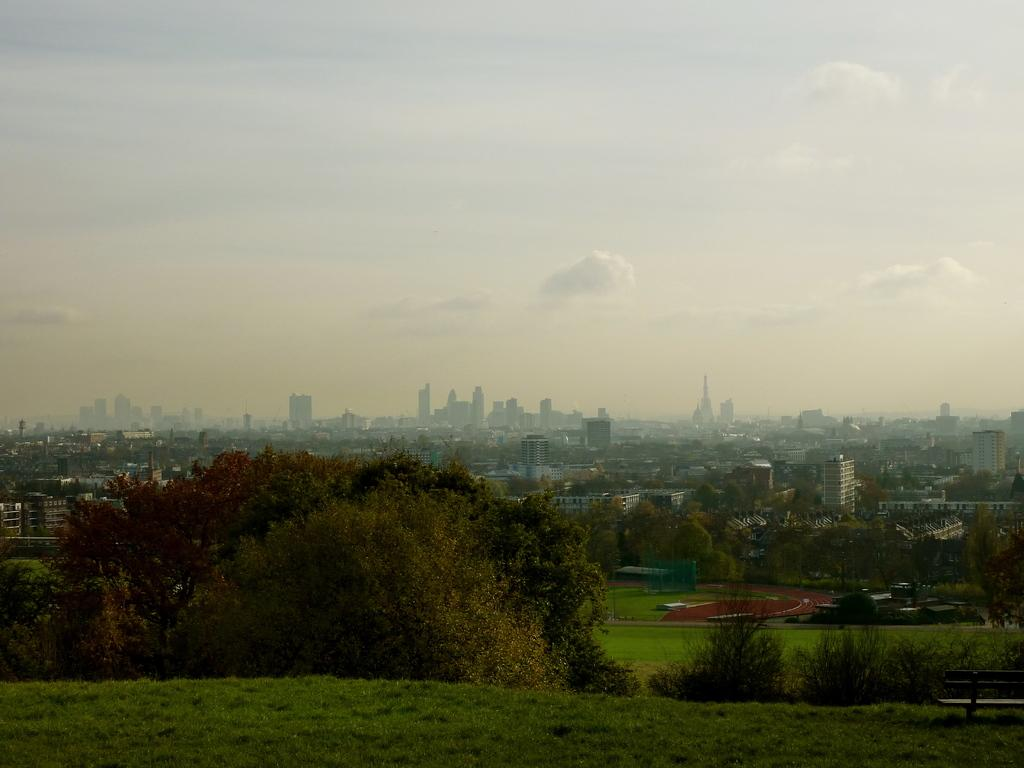What type of vegetation is present on the ground in the image? There are many trees on the ground in the image. What type of seating is available in the image? There is a bench to the right in the image. What type of structures can be seen in the background of the image? There are many buildings in the background of the image. What can be seen in the sky in the image? Clouds and the sky are visible in the background of the image. What type of cream is being sold at the shop in the image? There is no shop present in the image, so it is not possible to determine what type of cream might be sold there. What team is playing in the background of the image? There is no team or sports activity depicted in the image; it features trees, a bench, buildings, clouds, and the sky. 